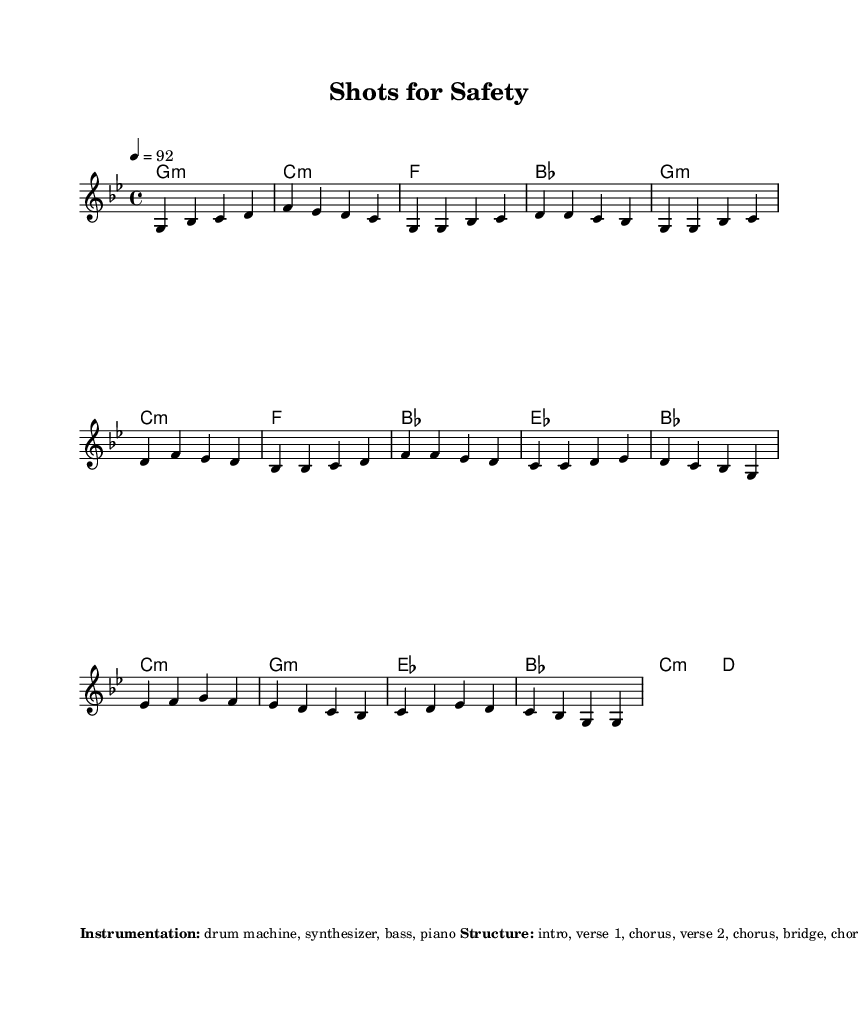What is the key signature of this music? The key signature is G minor, identified by the one flat (B flat) in the key signature section at the beginning of the sheet music.
Answer: G minor What is the time signature of the piece? The time signature is 4/4, indicated in the time signature section at the beginning of the score. This means there are four beats in a measure and a quarter note receives one beat.
Answer: 4/4 What is the tempo marking for the music? The tempo marking shows a speed of 92 beats per minute (BPM), which is specified in the tempo indication at the beginning of the score. This sets the pace for how fast the piece should be played.
Answer: 92 How many verses are there in the structure of the music? The structure of the music indicates there are two verses, as noted in the section entitled "Structure" found in the markup at the bottom.
Answer: 2 What instruments are used in the composition? The instruments listed in the "Instrumentation" section are drum machine, synthesizer, bass, and piano. This detail outlines the types of sounds that will be featured in the piece.
Answer: drum machine, synthesizer, bass, piano What is the main theme of the lyrics? The lyrics theme highlights the importance of vaccination and public health awareness, as outlined in the "Lyrics theme" section of the markup in the sheet music. This reflects the primary message conveyed through the song.
Answer: Importance of vaccination, public health awareness What part is labeled as the bridge in this music? The bridge is labeled as "Bridge" in the structure list, indicating a section that connects different parts of the song and provides contrast to the verses and chorus. In the music, it consists of specific melodic lines and harmonies.
Answer: Bridge 